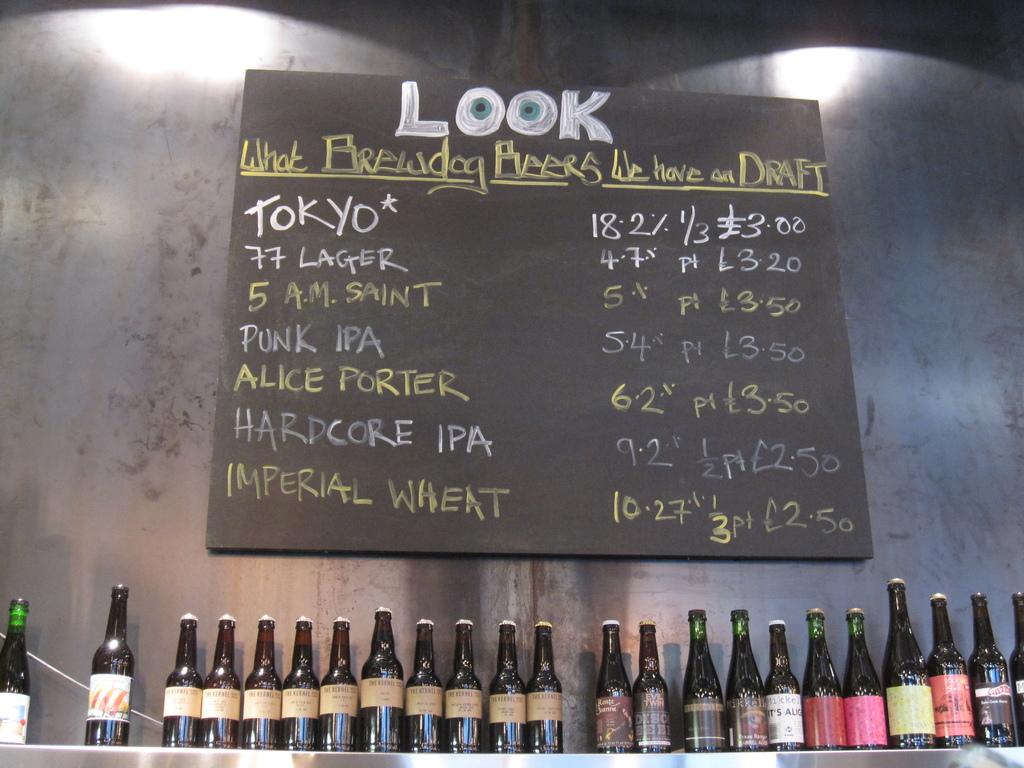Which drink is 10.27%?
Your answer should be compact. Imperial wheat. 